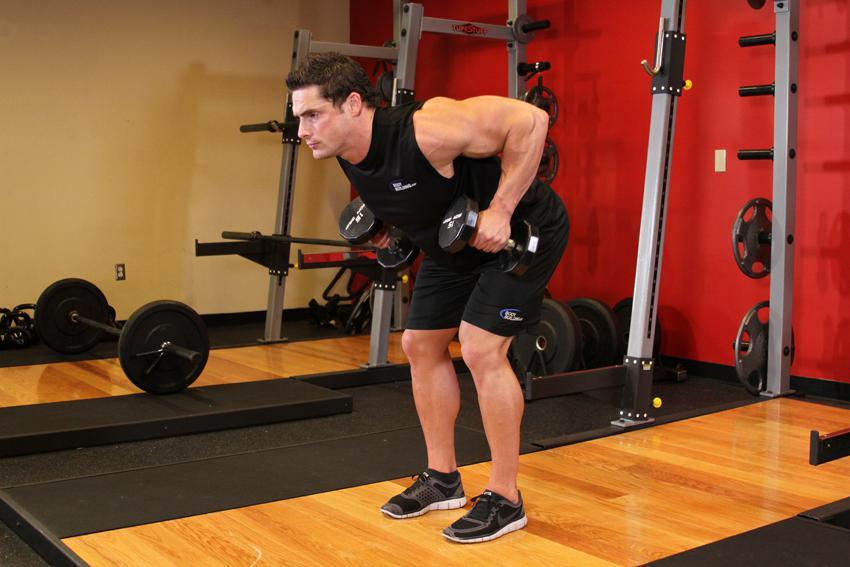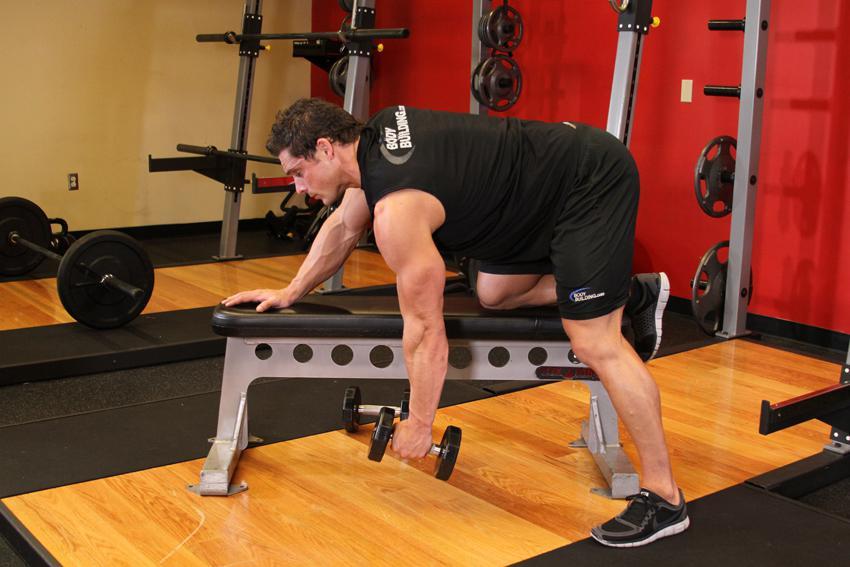The first image is the image on the left, the second image is the image on the right. Analyze the images presented: Is the assertion "There is a man dressed in black shorts and a red shirt in one of the images" valid? Answer yes or no. No. 